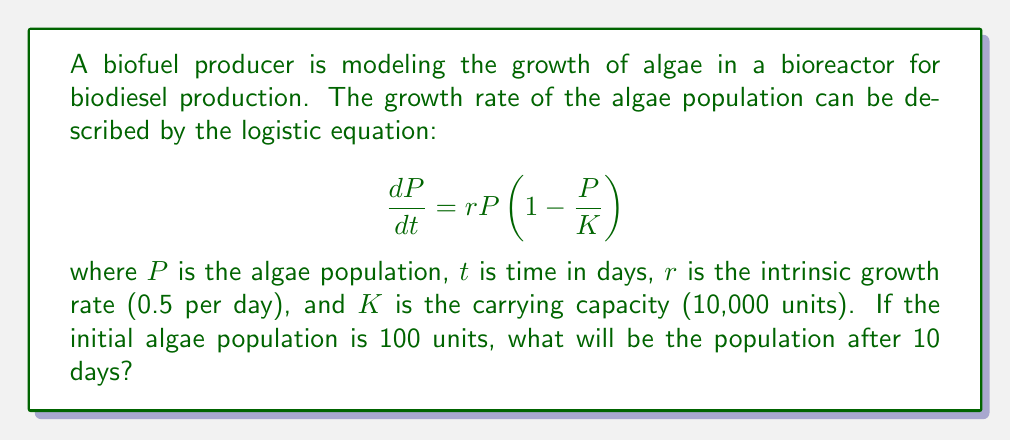Teach me how to tackle this problem. To solve this problem, we need to use the solution to the logistic equation:

$$P(t) = \frac{K}{1 + (\frac{K}{P_0} - 1)e^{-rt}}$$

Where:
$P(t)$ is the population at time $t$
$K$ is the carrying capacity (10,000 units)
$P_0$ is the initial population (100 units)
$r$ is the intrinsic growth rate (0.5 per day)
$t$ is the time (10 days)

Let's substitute these values into the equation:

$$P(10) = \frac{10000}{1 + (\frac{10000}{100} - 1)e^{-0.5 \cdot 10}}$$

Simplifying:

$$P(10) = \frac{10000}{1 + (99)e^{-5}}$$

Calculate $e^{-5}$:
$$e^{-5} \approx 0.00674$$

Substituting back:

$$P(10) = \frac{10000}{1 + 99 \cdot 0.00674}$$
$$P(10) = \frac{10000}{1 + 0.66726}$$
$$P(10) = \frac{10000}{1.66726}$$
$$P(10) \approx 5997.66$$

Rounding to the nearest whole number (as we're dealing with a population):

$$P(10) \approx 5998$$
Answer: 5998 units 